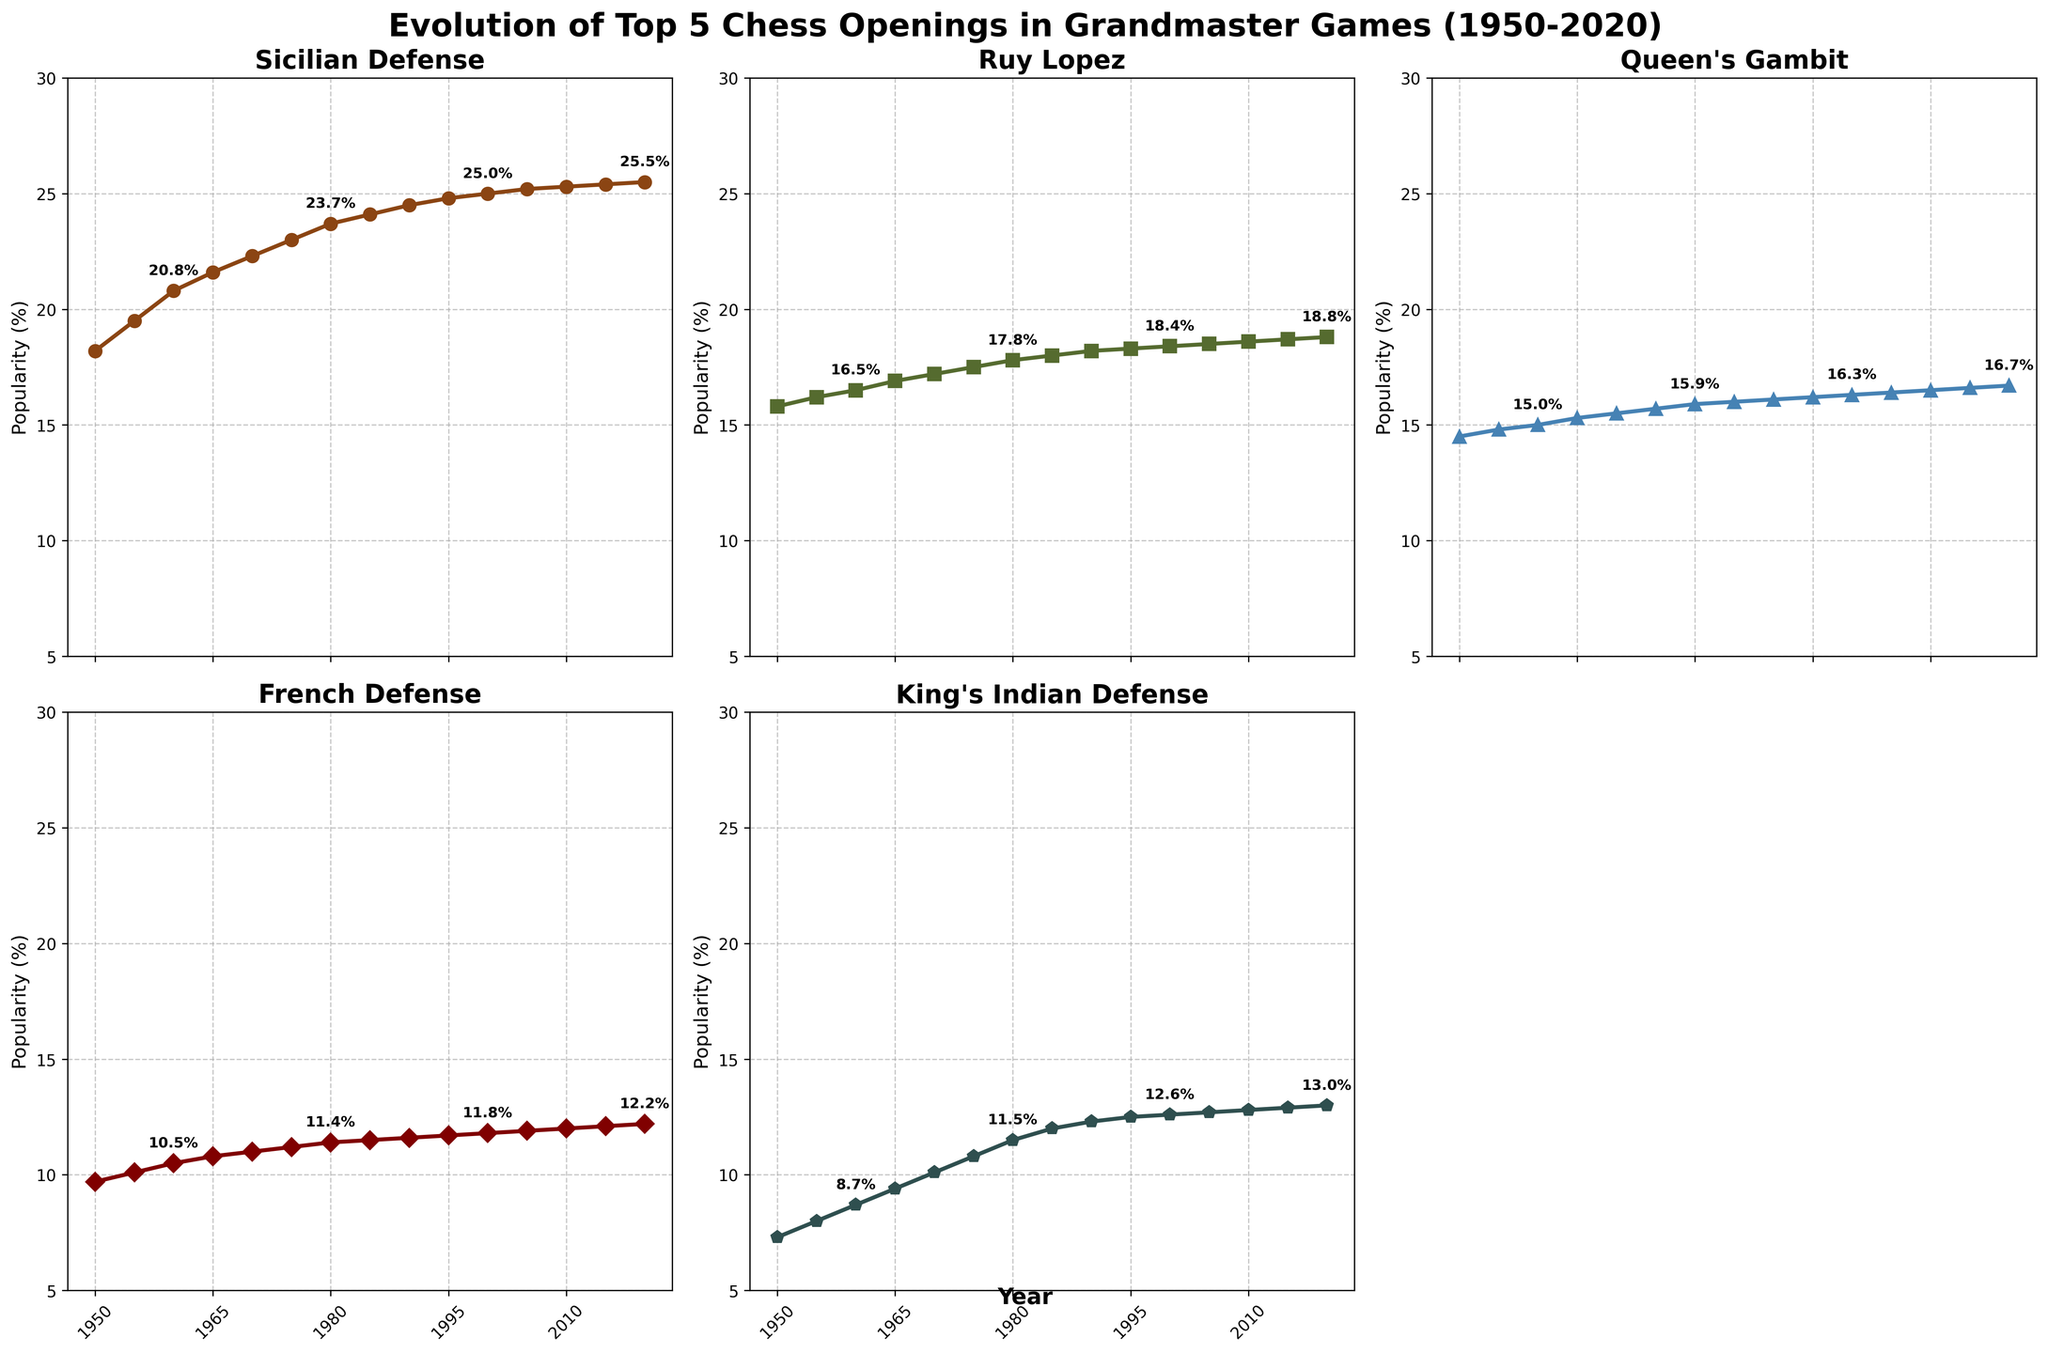What is the trend in the popularity of the Sicilian Defense from 1950 to 2020? The line plot for the Sicilian Defense shows a steady increase from around 18% in 1950 to 25.5% in 2020. The consistent upward trajectory indicates a growing preference for this opening among grandmasters over the 70-year period.
Answer: Increasing Which opening was more popular in 1970, Ruy Lopez or Queen’s Gambit? By looking at the data points for 1970, the Ruy Lopez mark is around 17.2% while the Queen’s Gambit mark is around 15.5%. Thus, the Ruy Lopez was more popular in 1970.
Answer: Ruy Lopez By how much did the popularity of the King’s Indian Defense increase from 1950 to 2020? The popularity of the King’s Indian Defense was 7.3% in 1950 and increased to 13.0% by 2020. The increase is 13.0% - 7.3% = 5.7%.
Answer: 5.7% Which opening showed the least amount of change in popularity between 1950 and 2020? The Queen’s Gambit started at 14.5% in 1950 and grew to 16.7% in 2020. This change is smaller compared to the other openings within the same period based on the slopes of the respective lines.
Answer: Queen's Gambit During which decade did the Sicilian Defense experience the most significant increase in popularity? By analyzing the slope of the line for the Sicilian Defense, the most significant increase occurred between 1950 and 1960, where it jumped from 18.2% to 20.8%, an increase of 2.6%.
Answer: 1950-1960 In 1985, which opening had the closest popularity percentage to the French Defense? In 1985, the French Defense's popularity was around 11.5%. The closest opening percentage in 1985 was the Queen’s Gambit, which was also 16.0%, quite close to 11.5%.
Answer: Queen's Gambit What is the average popularity of the King’s Indian Defense from 1950 to 2020? The values from the table are 7.3, 8.0, 8.7, 9.4, 10.1, 10.8, 11.5, 12.0, 12.3, 12.5, 12.6, 12.7, 12.8, 12.9, and 13.0. Summing these gives 168.6, and dividing by 15 gives an average of approximately 11.24%.
Answer: 11.24% Do Ruy Lopez and Queen’s Gambit show a similar trend in popularity evolution over time? Both Ruy Lopez and Queen's Gambit exhibit a generally increasing trend from 1950 to 2020. Ruy Lopez starts at 15.8% and ends at 18.8%, while Queen's Gambit starts at 14.5% and ends at 16.7%, indicating parallel upward trends albeit at different levels.
Answer: Yes 